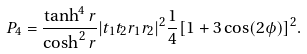<formula> <loc_0><loc_0><loc_500><loc_500>P _ { 4 } = \frac { \tanh ^ { 4 } r } { \cosh ^ { 2 } r } | t _ { 1 } t _ { 2 } r _ { 1 } r _ { 2 } | ^ { 2 } \frac { 1 } { 4 } [ 1 + 3 \cos ( 2 \phi ) ] ^ { 2 } .</formula> 